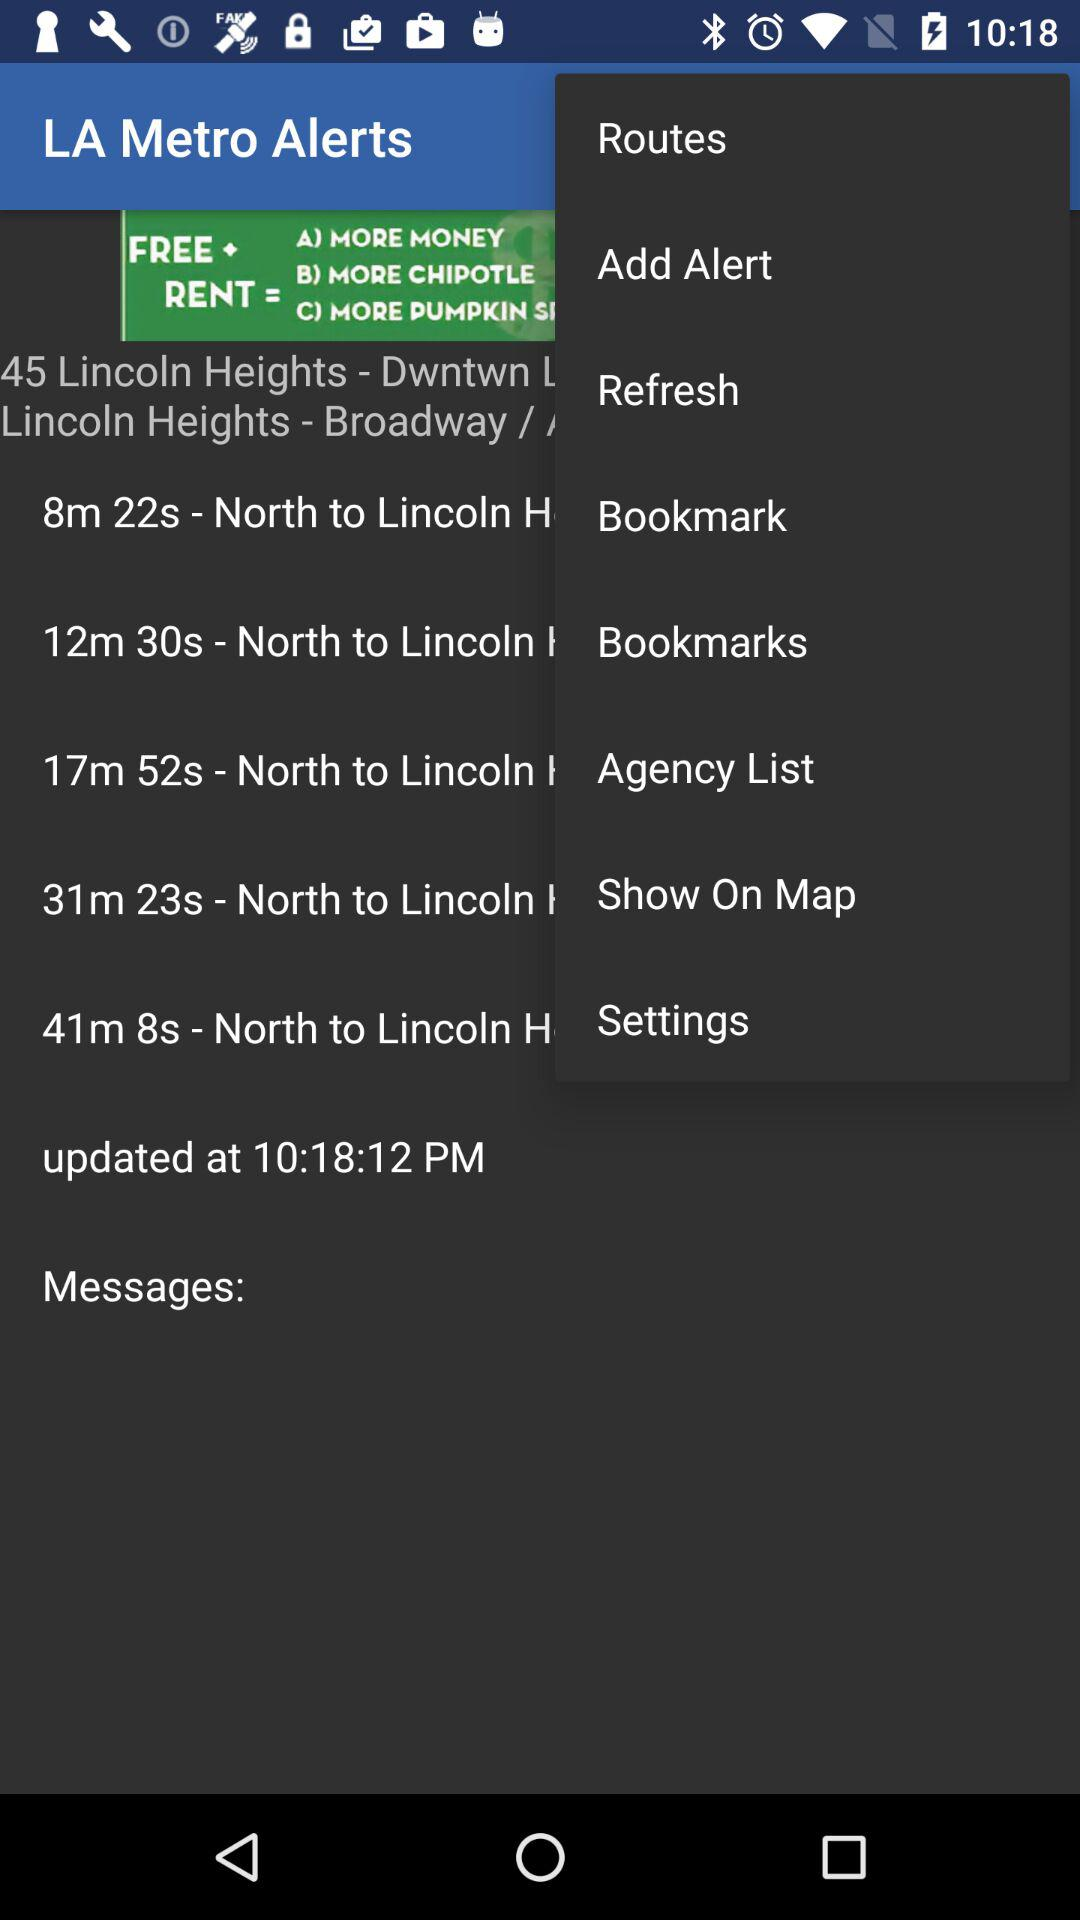What is the application name? The application name is "LA Metro Alerts". 